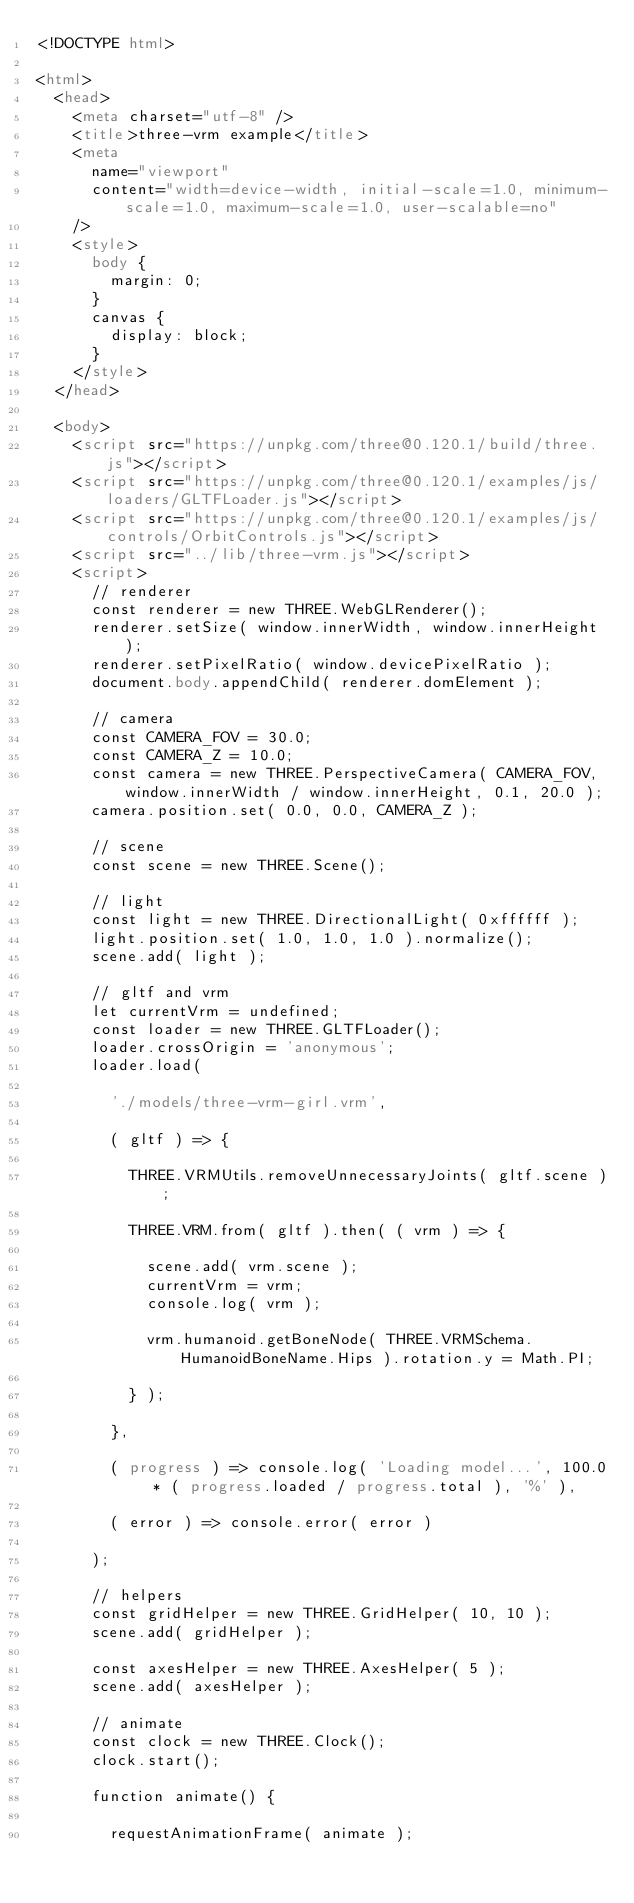<code> <loc_0><loc_0><loc_500><loc_500><_HTML_><!DOCTYPE html>

<html>
	<head>
		<meta charset="utf-8" />
		<title>three-vrm example</title>
		<meta
			name="viewport"
			content="width=device-width, initial-scale=1.0, minimum-scale=1.0, maximum-scale=1.0, user-scalable=no"
		/>
		<style>
			body {
				margin: 0;
			}
			canvas {
				display: block;
			}
		</style>
	</head>

	<body>
		<script src="https://unpkg.com/three@0.120.1/build/three.js"></script>
		<script src="https://unpkg.com/three@0.120.1/examples/js/loaders/GLTFLoader.js"></script>
		<script src="https://unpkg.com/three@0.120.1/examples/js/controls/OrbitControls.js"></script>
		<script src="../lib/three-vrm.js"></script>
		<script>
			// renderer
			const renderer = new THREE.WebGLRenderer();
			renderer.setSize( window.innerWidth, window.innerHeight );
			renderer.setPixelRatio( window.devicePixelRatio );
			document.body.appendChild( renderer.domElement );

			// camera
			const CAMERA_FOV = 30.0;
			const CAMERA_Z = 10.0;
			const camera = new THREE.PerspectiveCamera( CAMERA_FOV, window.innerWidth / window.innerHeight, 0.1, 20.0 );
			camera.position.set( 0.0, 0.0, CAMERA_Z );

			// scene
			const scene = new THREE.Scene();

			// light
			const light = new THREE.DirectionalLight( 0xffffff );
			light.position.set( 1.0, 1.0, 1.0 ).normalize();
			scene.add( light );

			// gltf and vrm
			let currentVrm = undefined;
			const loader = new THREE.GLTFLoader();
			loader.crossOrigin = 'anonymous';
			loader.load(

				'./models/three-vrm-girl.vrm',

				( gltf ) => {

					THREE.VRMUtils.removeUnnecessaryJoints( gltf.scene );

					THREE.VRM.from( gltf ).then( ( vrm ) => {

						scene.add( vrm.scene );
						currentVrm = vrm;
						console.log( vrm );

						vrm.humanoid.getBoneNode( THREE.VRMSchema.HumanoidBoneName.Hips ).rotation.y = Math.PI;

					} );

				},

				( progress ) => console.log( 'Loading model...', 100.0 * ( progress.loaded / progress.total ), '%' ),

				( error ) => console.error( error )

			);

			// helpers
			const gridHelper = new THREE.GridHelper( 10, 10 );
			scene.add( gridHelper );

			const axesHelper = new THREE.AxesHelper( 5 );
			scene.add( axesHelper );

			// animate
			const clock = new THREE.Clock();
			clock.start();

			function animate() {

				requestAnimationFrame( animate );
</code> 